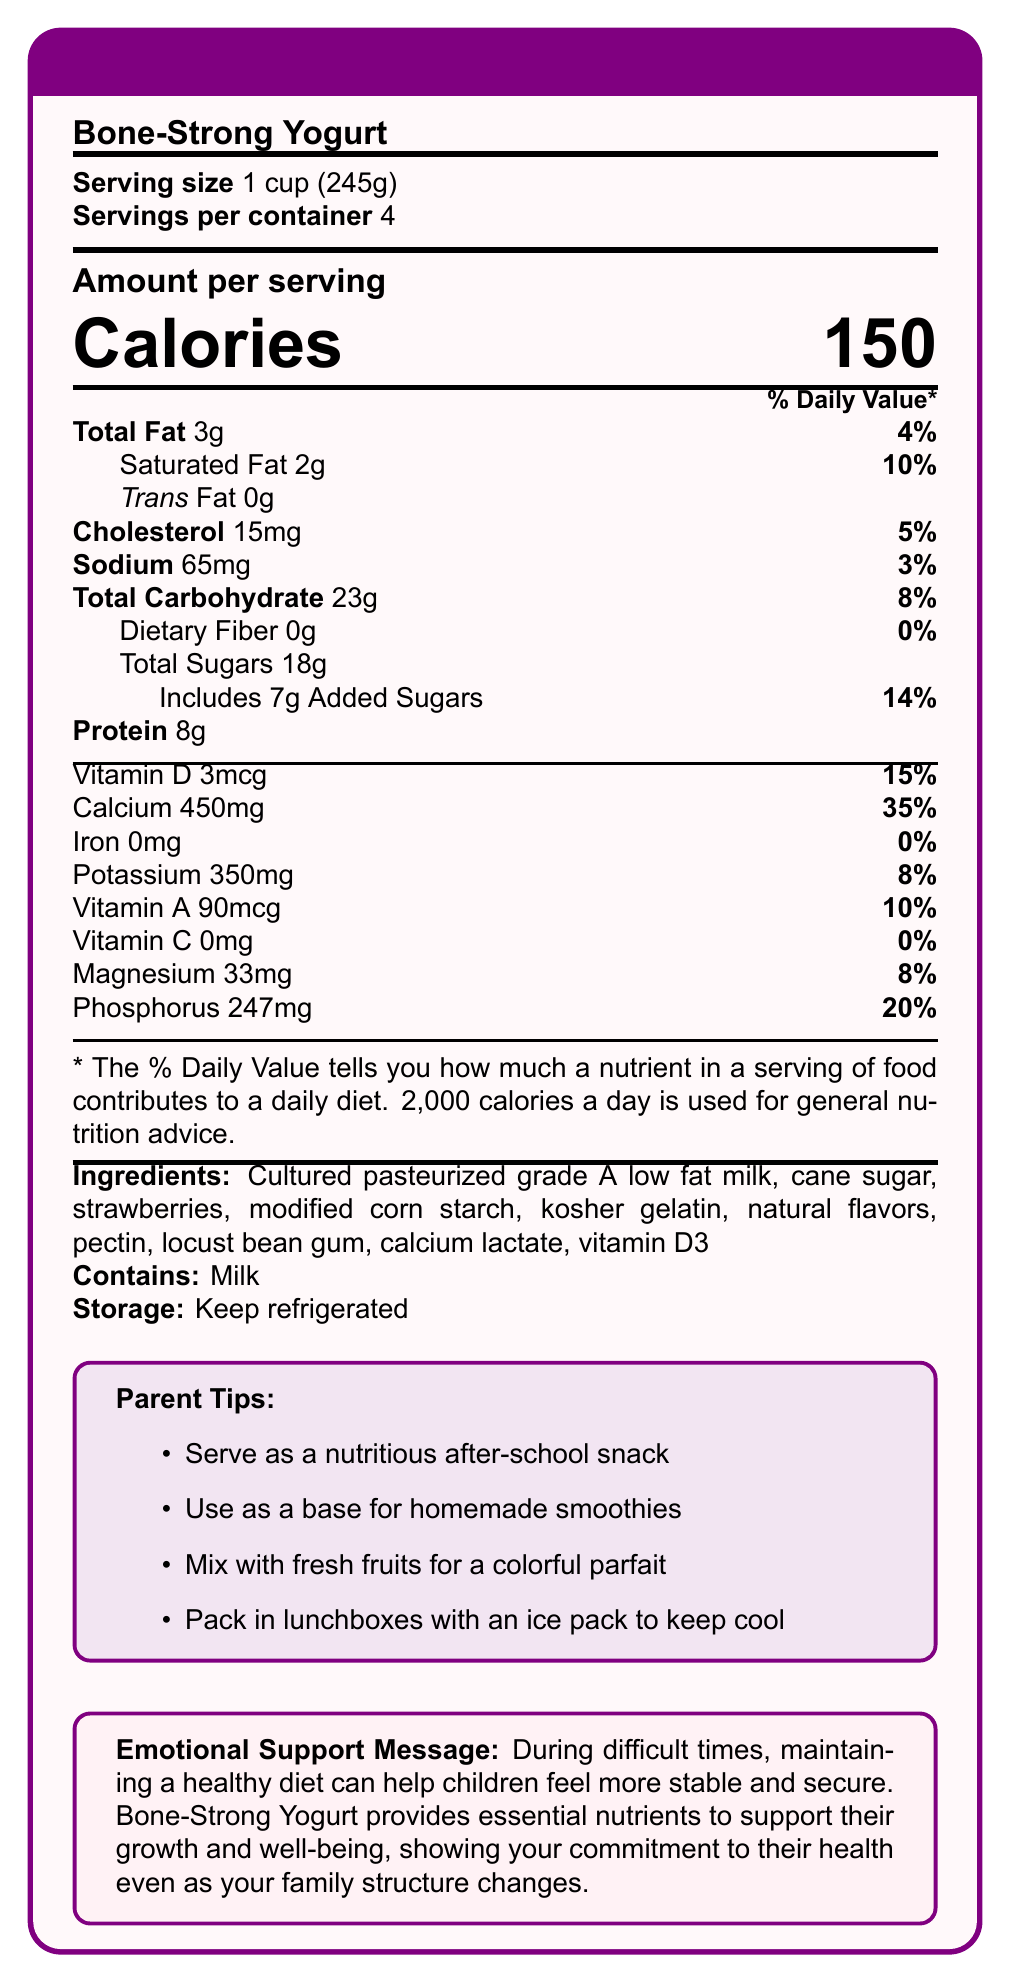what is the serving size of Bone-Strong Yogurt? The serving size is listed as "1 cup (245g)" in the Nutrition Facts section of the document.
Answer: 1 cup (245g) how much calcium does one serving of Bone-Strong Yogurt contain? The amount of calcium per serving is listed as "450mg" in the Nutrition Facts section.
Answer: 450mg what percentage of the daily value of Vitamin D does one serving provide? The percent daily value of Vitamin D per serving is listed as "15%" in the Nutrition Facts section.
Answer: 15% what is the total amount of sugar in one serving, including added sugar? The document lists "Total Sugars" as 18g, which includes 7g of added sugars.
Answer: 18g how many calories are in one serving of Bone-Strong Yogurt? The document lists each serving of Bone-Strong Yogurt as containing 150 calories.
Answer: 150 which of the following ingredients is NOT listed in Bone-Strong Yogurt? A. Cultured pasteurized grade A low fat milk B. Strawberries C. High fructose corn syrup D. Calcium lactate The ingredients list includes "Cultured pasteurized grade A low fat milk," "Strawberries," and "Calcium lactate" but does not include "High fructose corn syrup."
Answer: C how many servings are there per container? A. 2 B. 3 C. 4 D. 5 The servings per container are listed as "4" in the Nutrition Facts section.
Answer: C does Bone-Strong Yogurt contain any dietary fiber? Dietary fiber is listed as "0g" in the Nutrition Facts section, indicating that Bone-Strong Yogurt does not contain any dietary fiber.
Answer: No should Bone-Strong Yogurt be stored at room temperature? The Storage Instructions section states "Keep refrigerated," indicating that the yogurt should not be stored at room temperature.
Answer: No describe the main idea of the document. The document provides comprehensive information about Bone-Strong Yogurt, emphasizing its nutritional benefits, particularly in supporting children's bone health. It also includes practical tips for parents and a supportive message addressing the importance of a stable diet during family changes.
Answer: Bone-Strong Yogurt is a calcium-rich yogurt designed to support children's bone health, especially during stressful times, with detailed nutritional information, ingredients, storage instructions, tips for parents, and an emotional support message. does Bone-Strong Yogurt contain any iron? Iron is listed as "0mg" in the Nutrition Facts section, indicating that Bone-Strong Yogurt does not contain any iron.
Answer: No what is the main benefit of Bone-Strong Yogurt, according to the brand statement? The brand statement specifies that Bone-Strong Yogurt is specially formulated to support children's bone health.
Answer: Supports children's bone health what is the sodium content in one serving of Bone-Strong Yogurt? The sodium content per serving is listed as "65mg" in the Nutrition Facts section.
Answer: 65mg how can you use Bone-Strong Yogurt as suggested in the parent tips? A. Use as a base for homemade smoothies B. Mix with fresh fruits for a colorful parfait C. Serve as a nutritious after-school snack D. All of the above All three options are included in the parent tips, indicating multiple ways to use Bone-Strong Yogurt.
Answer: D is there any information about how Bone-Strong Yogurt affects energy levels? The document does not provide specific details about the impact of Bone-Strong Yogurt on energy levels.
Answer: Not enough information 